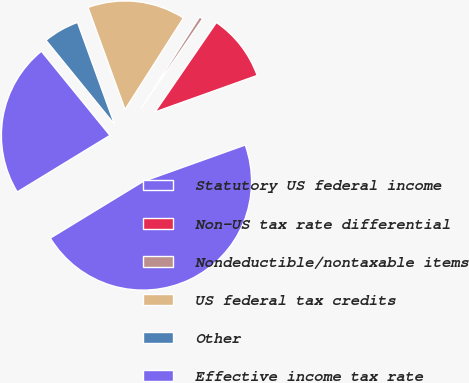Convert chart. <chart><loc_0><loc_0><loc_500><loc_500><pie_chart><fcel>Statutory US federal income<fcel>Non-US tax rate differential<fcel>Nondeductible/nontaxable items<fcel>US federal tax credits<fcel>Other<fcel>Effective income tax rate<nl><fcel>46.74%<fcel>9.96%<fcel>0.53%<fcel>14.58%<fcel>5.34%<fcel>22.84%<nl></chart> 